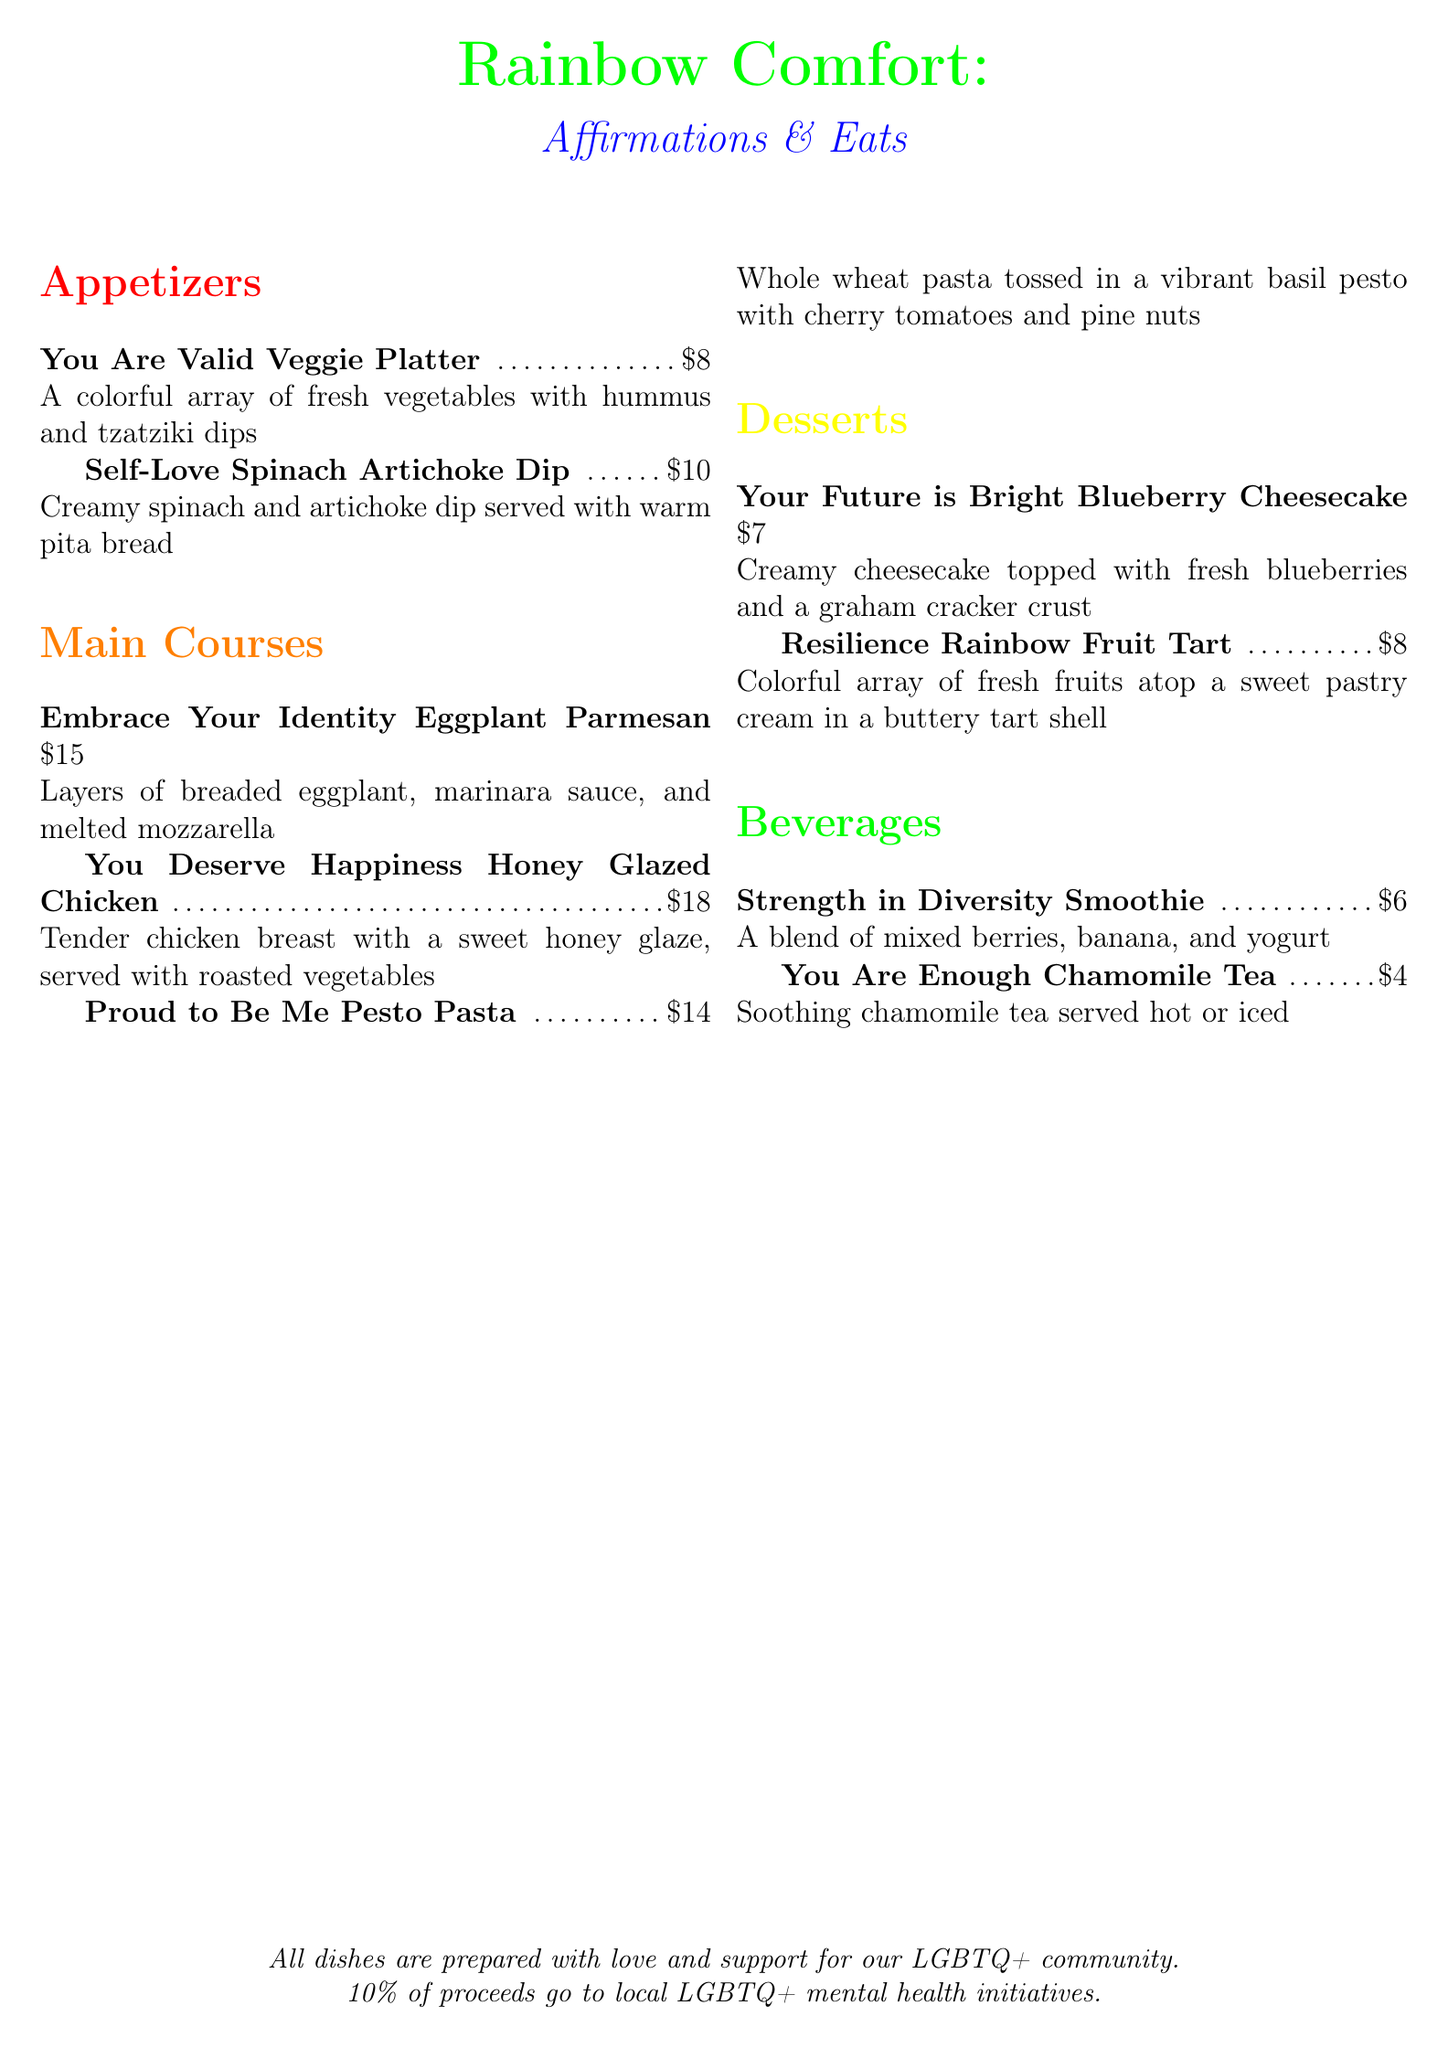What is the price of the You Are Valid Veggie Platter? The price is listed right next to the dish name.
Answer: $8 What type of dip is served with the Self-Love Spinach Artichoke Dip? The description states the dips served with the dish.
Answer: Hummus and tzatziki What is the main ingredient in the You Deserve Happiness Honey Glazed Chicken? The dish description mentions the main protein used.
Answer: Chicken breast How much does the Resilience Rainbow Fruit Tart cost? The price is indicated next to the dessert name.
Answer: $8 What is the main theme of the menu? The overall concept and theme of the menu can be inferred from the title.
Answer: Affirmations Which dish includes a graham cracker crust? The description highlights a specific feature of the dessert.
Answer: Your Future is Bright Blueberry Cheesecake What beverage is described as soothing? The document specifies a characteristic of one of the beverages.
Answer: You Are Enough Chamomile Tea How many appetizers are listed on the menu? The number of appetizers can be counted from the section.
Answer: 2 Which section comes after Desserts? The logical sequence in the menu can be referenced from the document sections.
Answer: Beverages What percentage of proceeds go to local LGBTQ+ mental health initiatives? The document clearly states this percentage in the note at the bottom.
Answer: 10% 